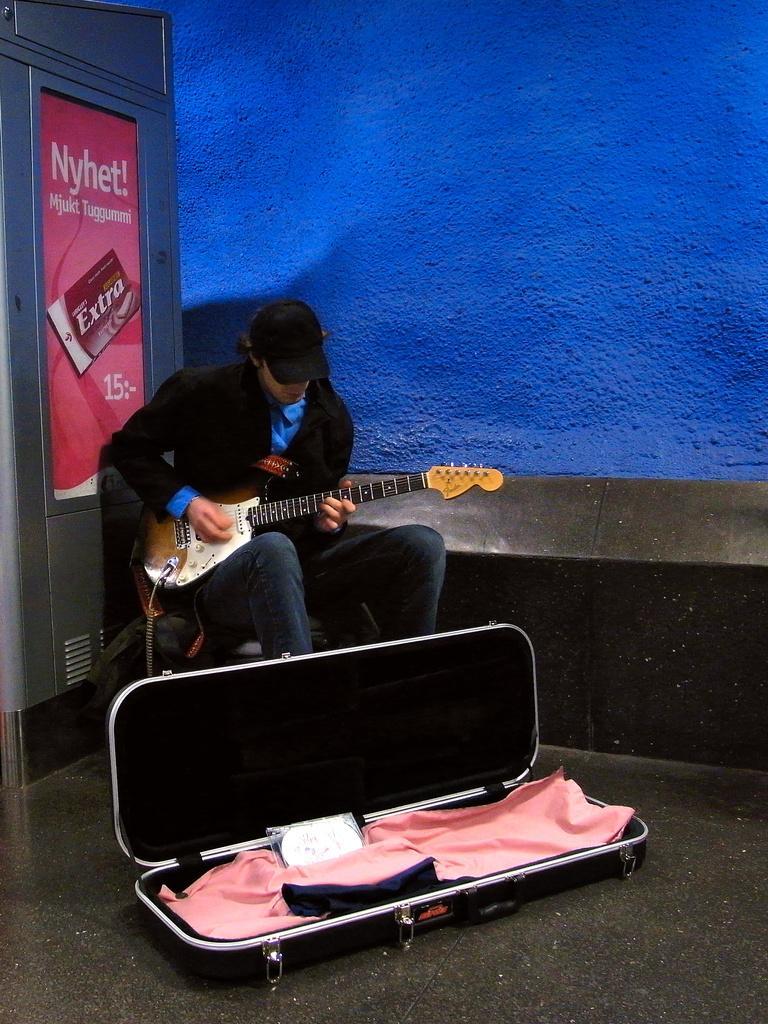How would you summarize this image in a sentence or two? In this image I can see a man who is sitting on a chair who is playing a guitar, wearing black suit and hat and in front of him we have a guitar box on the ground. On the right side of the image we have a blue color wall. 